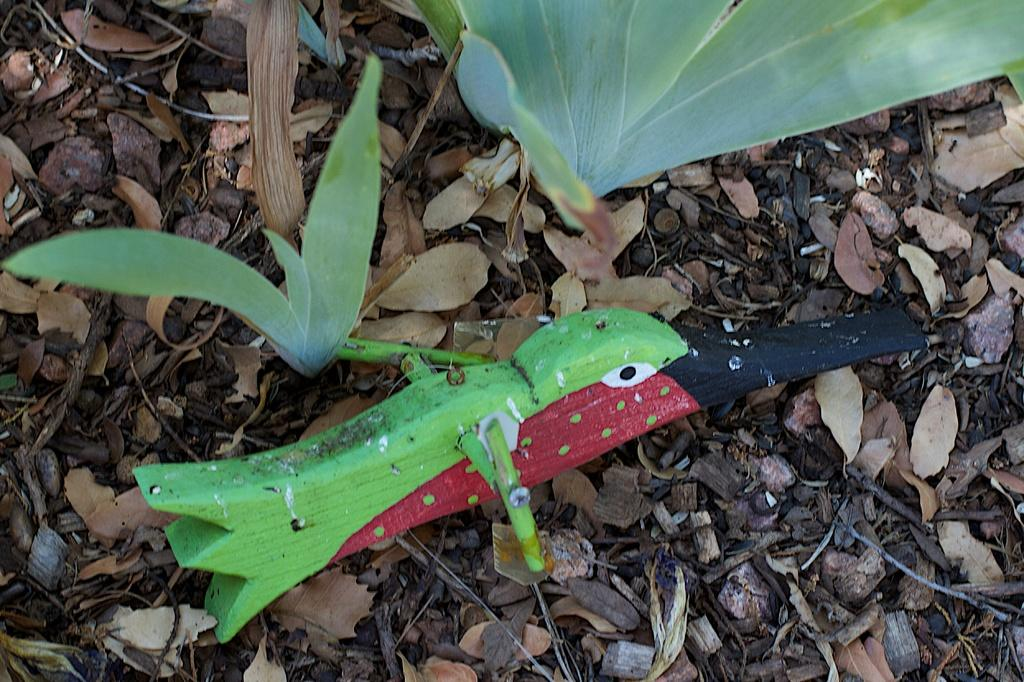What type of natural material can be seen in the image? There are dry leaves in the image. What type of living organisms are present in the image? There are plants in the image. What type of war is being depicted in the image? There is no depiction of war in the image; it features dry leaves and plants. How many lines can be seen in the image? There is no specific mention of lines in the image; it primarily consists of dry leaves and plants. 